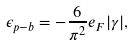Convert formula to latex. <formula><loc_0><loc_0><loc_500><loc_500>\epsilon _ { p - b } = - \frac { 6 } { \pi ^ { 2 } } e _ { F } | \gamma | ,</formula> 